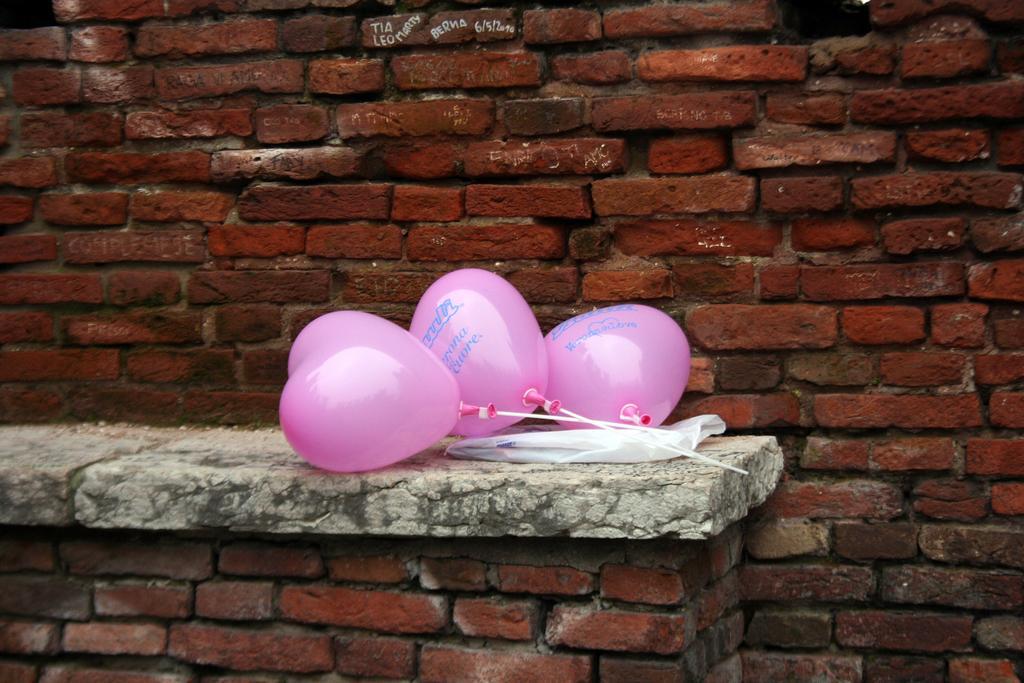Could you give a brief overview of what you see in this image? In this picture there are balloons and there is a cover on the wall and there is text on the balloons. At the back there is a building and there is a text on the wall. 